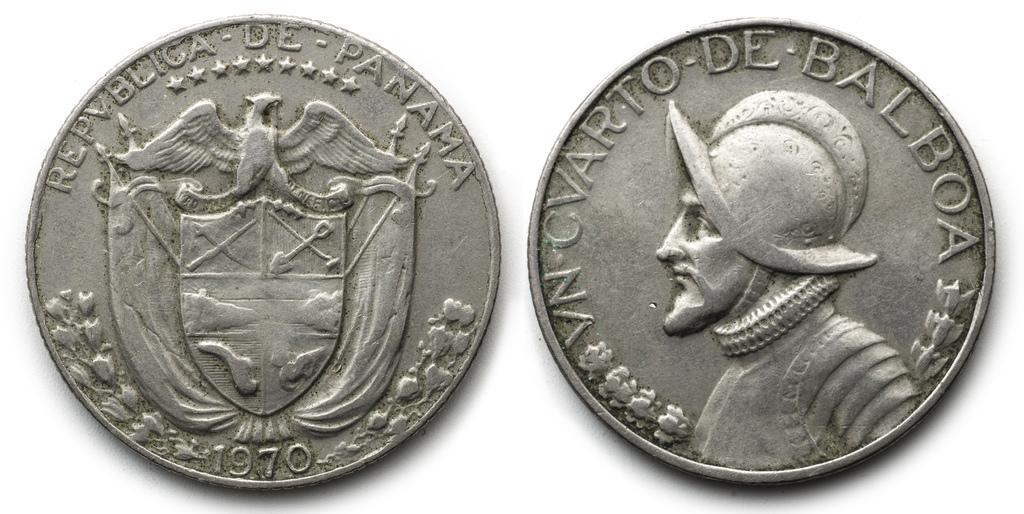<image>
Provide a brief description of the given image. A silver colored Republic of Panama coin from 1970. 